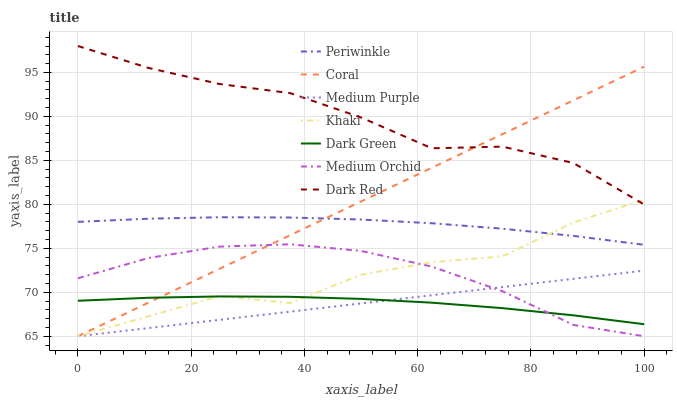Does Dark Green have the minimum area under the curve?
Answer yes or no. Yes. Does Dark Red have the maximum area under the curve?
Answer yes or no. Yes. Does Coral have the minimum area under the curve?
Answer yes or no. No. Does Coral have the maximum area under the curve?
Answer yes or no. No. Is Coral the smoothest?
Answer yes or no. Yes. Is Khaki the roughest?
Answer yes or no. Yes. Is Dark Red the smoothest?
Answer yes or no. No. Is Dark Red the roughest?
Answer yes or no. No. Does Khaki have the lowest value?
Answer yes or no. Yes. Does Dark Red have the lowest value?
Answer yes or no. No. Does Dark Red have the highest value?
Answer yes or no. Yes. Does Coral have the highest value?
Answer yes or no. No. Is Medium Purple less than Dark Red?
Answer yes or no. Yes. Is Dark Red greater than Medium Orchid?
Answer yes or no. Yes. Does Khaki intersect Periwinkle?
Answer yes or no. Yes. Is Khaki less than Periwinkle?
Answer yes or no. No. Is Khaki greater than Periwinkle?
Answer yes or no. No. Does Medium Purple intersect Dark Red?
Answer yes or no. No. 